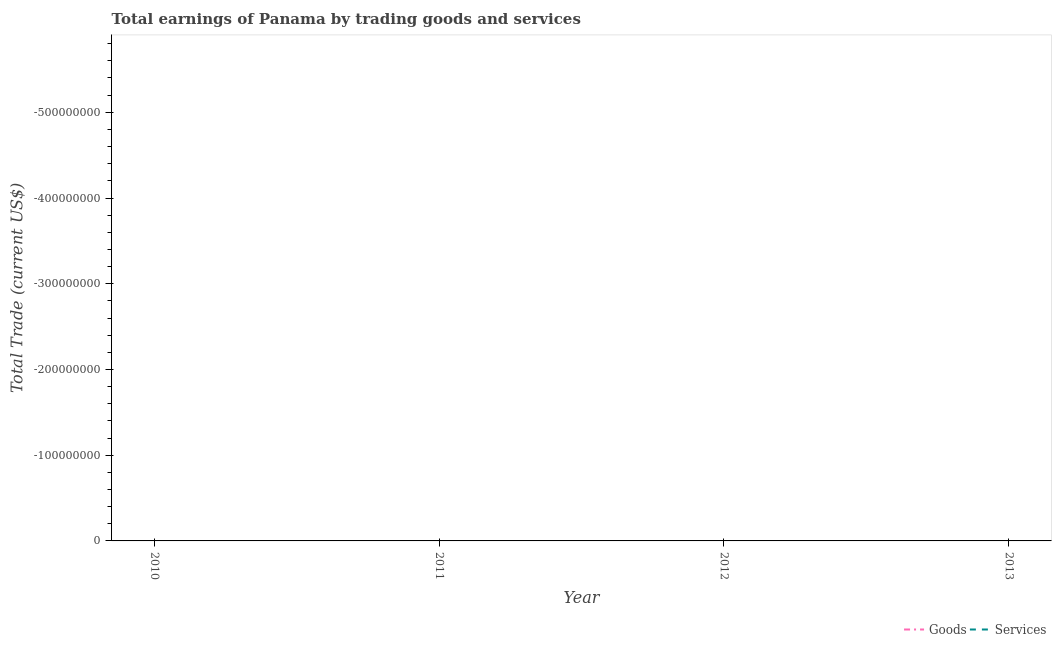How many different coloured lines are there?
Provide a short and direct response. 0. Does the line corresponding to amount earned by trading goods intersect with the line corresponding to amount earned by trading services?
Give a very brief answer. No. Is the number of lines equal to the number of legend labels?
Provide a short and direct response. No. What is the total amount earned by trading goods in the graph?
Give a very brief answer. 0. What is the difference between the amount earned by trading goods in 2010 and the amount earned by trading services in 2011?
Provide a succinct answer. 0. What is the average amount earned by trading goods per year?
Offer a very short reply. 0. In how many years, is the amount earned by trading goods greater than the average amount earned by trading goods taken over all years?
Your answer should be compact. 0. Is the amount earned by trading services strictly less than the amount earned by trading goods over the years?
Your answer should be compact. No. How many lines are there?
Provide a succinct answer. 0. What is the difference between two consecutive major ticks on the Y-axis?
Offer a terse response. 1.00e+08. Are the values on the major ticks of Y-axis written in scientific E-notation?
Ensure brevity in your answer.  No. Does the graph contain any zero values?
Ensure brevity in your answer.  Yes. Where does the legend appear in the graph?
Your answer should be compact. Bottom right. How many legend labels are there?
Offer a terse response. 2. What is the title of the graph?
Offer a terse response. Total earnings of Panama by trading goods and services. What is the label or title of the Y-axis?
Offer a terse response. Total Trade (current US$). What is the Total Trade (current US$) of Services in 2010?
Your response must be concise. 0. What is the Total Trade (current US$) of Services in 2011?
Provide a succinct answer. 0. What is the Total Trade (current US$) of Goods in 2012?
Ensure brevity in your answer.  0. What is the Total Trade (current US$) of Goods in 2013?
Keep it short and to the point. 0. What is the total Total Trade (current US$) in Goods in the graph?
Your answer should be very brief. 0. What is the total Total Trade (current US$) of Services in the graph?
Make the answer very short. 0. What is the average Total Trade (current US$) in Goods per year?
Make the answer very short. 0. What is the average Total Trade (current US$) of Services per year?
Make the answer very short. 0. 